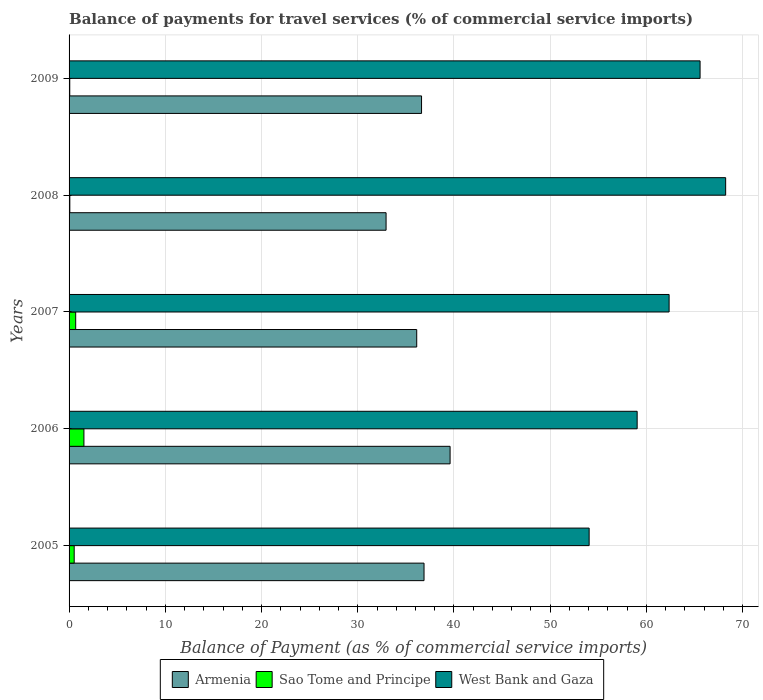How many groups of bars are there?
Ensure brevity in your answer.  5. Are the number of bars per tick equal to the number of legend labels?
Your answer should be very brief. Yes. Are the number of bars on each tick of the Y-axis equal?
Make the answer very short. Yes. What is the label of the 5th group of bars from the top?
Your answer should be compact. 2005. What is the balance of payments for travel services in Armenia in 2006?
Give a very brief answer. 39.6. Across all years, what is the maximum balance of payments for travel services in Sao Tome and Principe?
Your answer should be very brief. 1.54. Across all years, what is the minimum balance of payments for travel services in Armenia?
Offer a terse response. 32.94. What is the total balance of payments for travel services in West Bank and Gaza in the graph?
Give a very brief answer. 309.24. What is the difference between the balance of payments for travel services in Sao Tome and Principe in 2006 and that in 2007?
Your response must be concise. 0.86. What is the difference between the balance of payments for travel services in Sao Tome and Principe in 2006 and the balance of payments for travel services in West Bank and Gaza in 2005?
Your answer should be very brief. -52.5. What is the average balance of payments for travel services in West Bank and Gaza per year?
Offer a terse response. 61.85. In the year 2008, what is the difference between the balance of payments for travel services in West Bank and Gaza and balance of payments for travel services in Sao Tome and Principe?
Provide a short and direct response. 68.15. In how many years, is the balance of payments for travel services in Armenia greater than 34 %?
Your answer should be very brief. 4. What is the ratio of the balance of payments for travel services in Armenia in 2005 to that in 2007?
Offer a very short reply. 1.02. Is the balance of payments for travel services in West Bank and Gaza in 2008 less than that in 2009?
Your answer should be very brief. No. What is the difference between the highest and the second highest balance of payments for travel services in Sao Tome and Principe?
Your response must be concise. 0.86. What is the difference between the highest and the lowest balance of payments for travel services in Armenia?
Your answer should be compact. 6.65. What does the 1st bar from the top in 2009 represents?
Make the answer very short. West Bank and Gaza. What does the 2nd bar from the bottom in 2007 represents?
Ensure brevity in your answer.  Sao Tome and Principe. Is it the case that in every year, the sum of the balance of payments for travel services in Sao Tome and Principe and balance of payments for travel services in Armenia is greater than the balance of payments for travel services in West Bank and Gaza?
Make the answer very short. No. Are all the bars in the graph horizontal?
Offer a terse response. Yes. How many years are there in the graph?
Ensure brevity in your answer.  5. What is the difference between two consecutive major ticks on the X-axis?
Your answer should be compact. 10. Are the values on the major ticks of X-axis written in scientific E-notation?
Your response must be concise. No. Does the graph contain any zero values?
Give a very brief answer. No. Where does the legend appear in the graph?
Your answer should be very brief. Bottom center. How many legend labels are there?
Give a very brief answer. 3. What is the title of the graph?
Your answer should be compact. Balance of payments for travel services (% of commercial service imports). What is the label or title of the X-axis?
Your response must be concise. Balance of Payment (as % of commercial service imports). What is the Balance of Payment (as % of commercial service imports) in Armenia in 2005?
Make the answer very short. 36.89. What is the Balance of Payment (as % of commercial service imports) of Sao Tome and Principe in 2005?
Your response must be concise. 0.53. What is the Balance of Payment (as % of commercial service imports) of West Bank and Gaza in 2005?
Your response must be concise. 54.05. What is the Balance of Payment (as % of commercial service imports) in Armenia in 2006?
Offer a terse response. 39.6. What is the Balance of Payment (as % of commercial service imports) of Sao Tome and Principe in 2006?
Offer a very short reply. 1.54. What is the Balance of Payment (as % of commercial service imports) of West Bank and Gaza in 2006?
Provide a short and direct response. 59.04. What is the Balance of Payment (as % of commercial service imports) in Armenia in 2007?
Your answer should be compact. 36.13. What is the Balance of Payment (as % of commercial service imports) in Sao Tome and Principe in 2007?
Your response must be concise. 0.69. What is the Balance of Payment (as % of commercial service imports) of West Bank and Gaza in 2007?
Your answer should be compact. 62.36. What is the Balance of Payment (as % of commercial service imports) in Armenia in 2008?
Ensure brevity in your answer.  32.94. What is the Balance of Payment (as % of commercial service imports) of Sao Tome and Principe in 2008?
Provide a short and direct response. 0.08. What is the Balance of Payment (as % of commercial service imports) in West Bank and Gaza in 2008?
Your answer should be compact. 68.23. What is the Balance of Payment (as % of commercial service imports) in Armenia in 2009?
Your response must be concise. 36.63. What is the Balance of Payment (as % of commercial service imports) in Sao Tome and Principe in 2009?
Provide a short and direct response. 0.07. What is the Balance of Payment (as % of commercial service imports) in West Bank and Gaza in 2009?
Your response must be concise. 65.57. Across all years, what is the maximum Balance of Payment (as % of commercial service imports) of Armenia?
Provide a succinct answer. 39.6. Across all years, what is the maximum Balance of Payment (as % of commercial service imports) of Sao Tome and Principe?
Your response must be concise. 1.54. Across all years, what is the maximum Balance of Payment (as % of commercial service imports) of West Bank and Gaza?
Ensure brevity in your answer.  68.23. Across all years, what is the minimum Balance of Payment (as % of commercial service imports) in Armenia?
Provide a short and direct response. 32.94. Across all years, what is the minimum Balance of Payment (as % of commercial service imports) in Sao Tome and Principe?
Provide a short and direct response. 0.07. Across all years, what is the minimum Balance of Payment (as % of commercial service imports) of West Bank and Gaza?
Keep it short and to the point. 54.05. What is the total Balance of Payment (as % of commercial service imports) in Armenia in the graph?
Provide a succinct answer. 182.18. What is the total Balance of Payment (as % of commercial service imports) of Sao Tome and Principe in the graph?
Provide a succinct answer. 2.91. What is the total Balance of Payment (as % of commercial service imports) in West Bank and Gaza in the graph?
Give a very brief answer. 309.24. What is the difference between the Balance of Payment (as % of commercial service imports) of Armenia in 2005 and that in 2006?
Provide a short and direct response. -2.71. What is the difference between the Balance of Payment (as % of commercial service imports) in Sao Tome and Principe in 2005 and that in 2006?
Keep it short and to the point. -1.01. What is the difference between the Balance of Payment (as % of commercial service imports) in West Bank and Gaza in 2005 and that in 2006?
Your answer should be very brief. -4.99. What is the difference between the Balance of Payment (as % of commercial service imports) in Armenia in 2005 and that in 2007?
Provide a succinct answer. 0.76. What is the difference between the Balance of Payment (as % of commercial service imports) in Sao Tome and Principe in 2005 and that in 2007?
Your answer should be compact. -0.16. What is the difference between the Balance of Payment (as % of commercial service imports) in West Bank and Gaza in 2005 and that in 2007?
Your answer should be compact. -8.31. What is the difference between the Balance of Payment (as % of commercial service imports) in Armenia in 2005 and that in 2008?
Your answer should be very brief. 3.94. What is the difference between the Balance of Payment (as % of commercial service imports) in Sao Tome and Principe in 2005 and that in 2008?
Your response must be concise. 0.45. What is the difference between the Balance of Payment (as % of commercial service imports) in West Bank and Gaza in 2005 and that in 2008?
Keep it short and to the point. -14.19. What is the difference between the Balance of Payment (as % of commercial service imports) in Armenia in 2005 and that in 2009?
Your response must be concise. 0.26. What is the difference between the Balance of Payment (as % of commercial service imports) of Sao Tome and Principe in 2005 and that in 2009?
Offer a terse response. 0.46. What is the difference between the Balance of Payment (as % of commercial service imports) of West Bank and Gaza in 2005 and that in 2009?
Offer a very short reply. -11.53. What is the difference between the Balance of Payment (as % of commercial service imports) of Armenia in 2006 and that in 2007?
Provide a succinct answer. 3.47. What is the difference between the Balance of Payment (as % of commercial service imports) of Sao Tome and Principe in 2006 and that in 2007?
Your response must be concise. 0.86. What is the difference between the Balance of Payment (as % of commercial service imports) of West Bank and Gaza in 2006 and that in 2007?
Provide a short and direct response. -3.32. What is the difference between the Balance of Payment (as % of commercial service imports) of Armenia in 2006 and that in 2008?
Give a very brief answer. 6.65. What is the difference between the Balance of Payment (as % of commercial service imports) of Sao Tome and Principe in 2006 and that in 2008?
Offer a terse response. 1.47. What is the difference between the Balance of Payment (as % of commercial service imports) of West Bank and Gaza in 2006 and that in 2008?
Offer a terse response. -9.2. What is the difference between the Balance of Payment (as % of commercial service imports) in Armenia in 2006 and that in 2009?
Offer a terse response. 2.97. What is the difference between the Balance of Payment (as % of commercial service imports) of Sao Tome and Principe in 2006 and that in 2009?
Your response must be concise. 1.47. What is the difference between the Balance of Payment (as % of commercial service imports) in West Bank and Gaza in 2006 and that in 2009?
Offer a very short reply. -6.54. What is the difference between the Balance of Payment (as % of commercial service imports) of Armenia in 2007 and that in 2008?
Keep it short and to the point. 3.18. What is the difference between the Balance of Payment (as % of commercial service imports) in Sao Tome and Principe in 2007 and that in 2008?
Provide a short and direct response. 0.61. What is the difference between the Balance of Payment (as % of commercial service imports) of West Bank and Gaza in 2007 and that in 2008?
Ensure brevity in your answer.  -5.88. What is the difference between the Balance of Payment (as % of commercial service imports) of Armenia in 2007 and that in 2009?
Your answer should be compact. -0.5. What is the difference between the Balance of Payment (as % of commercial service imports) in Sao Tome and Principe in 2007 and that in 2009?
Keep it short and to the point. 0.62. What is the difference between the Balance of Payment (as % of commercial service imports) of West Bank and Gaza in 2007 and that in 2009?
Ensure brevity in your answer.  -3.22. What is the difference between the Balance of Payment (as % of commercial service imports) in Armenia in 2008 and that in 2009?
Make the answer very short. -3.69. What is the difference between the Balance of Payment (as % of commercial service imports) of Sao Tome and Principe in 2008 and that in 2009?
Offer a very short reply. 0.01. What is the difference between the Balance of Payment (as % of commercial service imports) in West Bank and Gaza in 2008 and that in 2009?
Offer a very short reply. 2.66. What is the difference between the Balance of Payment (as % of commercial service imports) of Armenia in 2005 and the Balance of Payment (as % of commercial service imports) of Sao Tome and Principe in 2006?
Ensure brevity in your answer.  35.34. What is the difference between the Balance of Payment (as % of commercial service imports) in Armenia in 2005 and the Balance of Payment (as % of commercial service imports) in West Bank and Gaza in 2006?
Your response must be concise. -22.15. What is the difference between the Balance of Payment (as % of commercial service imports) in Sao Tome and Principe in 2005 and the Balance of Payment (as % of commercial service imports) in West Bank and Gaza in 2006?
Provide a succinct answer. -58.5. What is the difference between the Balance of Payment (as % of commercial service imports) in Armenia in 2005 and the Balance of Payment (as % of commercial service imports) in Sao Tome and Principe in 2007?
Make the answer very short. 36.2. What is the difference between the Balance of Payment (as % of commercial service imports) in Armenia in 2005 and the Balance of Payment (as % of commercial service imports) in West Bank and Gaza in 2007?
Your answer should be compact. -25.47. What is the difference between the Balance of Payment (as % of commercial service imports) in Sao Tome and Principe in 2005 and the Balance of Payment (as % of commercial service imports) in West Bank and Gaza in 2007?
Your response must be concise. -61.82. What is the difference between the Balance of Payment (as % of commercial service imports) in Armenia in 2005 and the Balance of Payment (as % of commercial service imports) in Sao Tome and Principe in 2008?
Keep it short and to the point. 36.81. What is the difference between the Balance of Payment (as % of commercial service imports) of Armenia in 2005 and the Balance of Payment (as % of commercial service imports) of West Bank and Gaza in 2008?
Offer a very short reply. -31.35. What is the difference between the Balance of Payment (as % of commercial service imports) of Sao Tome and Principe in 2005 and the Balance of Payment (as % of commercial service imports) of West Bank and Gaza in 2008?
Keep it short and to the point. -67.7. What is the difference between the Balance of Payment (as % of commercial service imports) in Armenia in 2005 and the Balance of Payment (as % of commercial service imports) in Sao Tome and Principe in 2009?
Keep it short and to the point. 36.82. What is the difference between the Balance of Payment (as % of commercial service imports) of Armenia in 2005 and the Balance of Payment (as % of commercial service imports) of West Bank and Gaza in 2009?
Provide a succinct answer. -28.69. What is the difference between the Balance of Payment (as % of commercial service imports) of Sao Tome and Principe in 2005 and the Balance of Payment (as % of commercial service imports) of West Bank and Gaza in 2009?
Offer a very short reply. -65.04. What is the difference between the Balance of Payment (as % of commercial service imports) of Armenia in 2006 and the Balance of Payment (as % of commercial service imports) of Sao Tome and Principe in 2007?
Ensure brevity in your answer.  38.91. What is the difference between the Balance of Payment (as % of commercial service imports) of Armenia in 2006 and the Balance of Payment (as % of commercial service imports) of West Bank and Gaza in 2007?
Offer a terse response. -22.76. What is the difference between the Balance of Payment (as % of commercial service imports) of Sao Tome and Principe in 2006 and the Balance of Payment (as % of commercial service imports) of West Bank and Gaza in 2007?
Your answer should be very brief. -60.81. What is the difference between the Balance of Payment (as % of commercial service imports) in Armenia in 2006 and the Balance of Payment (as % of commercial service imports) in Sao Tome and Principe in 2008?
Give a very brief answer. 39.52. What is the difference between the Balance of Payment (as % of commercial service imports) in Armenia in 2006 and the Balance of Payment (as % of commercial service imports) in West Bank and Gaza in 2008?
Keep it short and to the point. -28.64. What is the difference between the Balance of Payment (as % of commercial service imports) of Sao Tome and Principe in 2006 and the Balance of Payment (as % of commercial service imports) of West Bank and Gaza in 2008?
Your answer should be very brief. -66.69. What is the difference between the Balance of Payment (as % of commercial service imports) of Armenia in 2006 and the Balance of Payment (as % of commercial service imports) of Sao Tome and Principe in 2009?
Keep it short and to the point. 39.52. What is the difference between the Balance of Payment (as % of commercial service imports) of Armenia in 2006 and the Balance of Payment (as % of commercial service imports) of West Bank and Gaza in 2009?
Make the answer very short. -25.98. What is the difference between the Balance of Payment (as % of commercial service imports) in Sao Tome and Principe in 2006 and the Balance of Payment (as % of commercial service imports) in West Bank and Gaza in 2009?
Your response must be concise. -64.03. What is the difference between the Balance of Payment (as % of commercial service imports) of Armenia in 2007 and the Balance of Payment (as % of commercial service imports) of Sao Tome and Principe in 2008?
Your answer should be very brief. 36.05. What is the difference between the Balance of Payment (as % of commercial service imports) of Armenia in 2007 and the Balance of Payment (as % of commercial service imports) of West Bank and Gaza in 2008?
Give a very brief answer. -32.1. What is the difference between the Balance of Payment (as % of commercial service imports) of Sao Tome and Principe in 2007 and the Balance of Payment (as % of commercial service imports) of West Bank and Gaza in 2008?
Ensure brevity in your answer.  -67.54. What is the difference between the Balance of Payment (as % of commercial service imports) in Armenia in 2007 and the Balance of Payment (as % of commercial service imports) in Sao Tome and Principe in 2009?
Offer a very short reply. 36.06. What is the difference between the Balance of Payment (as % of commercial service imports) in Armenia in 2007 and the Balance of Payment (as % of commercial service imports) in West Bank and Gaza in 2009?
Provide a short and direct response. -29.45. What is the difference between the Balance of Payment (as % of commercial service imports) in Sao Tome and Principe in 2007 and the Balance of Payment (as % of commercial service imports) in West Bank and Gaza in 2009?
Keep it short and to the point. -64.89. What is the difference between the Balance of Payment (as % of commercial service imports) in Armenia in 2008 and the Balance of Payment (as % of commercial service imports) in Sao Tome and Principe in 2009?
Make the answer very short. 32.87. What is the difference between the Balance of Payment (as % of commercial service imports) of Armenia in 2008 and the Balance of Payment (as % of commercial service imports) of West Bank and Gaza in 2009?
Provide a short and direct response. -32.63. What is the difference between the Balance of Payment (as % of commercial service imports) of Sao Tome and Principe in 2008 and the Balance of Payment (as % of commercial service imports) of West Bank and Gaza in 2009?
Offer a very short reply. -65.5. What is the average Balance of Payment (as % of commercial service imports) in Armenia per year?
Offer a terse response. 36.44. What is the average Balance of Payment (as % of commercial service imports) of Sao Tome and Principe per year?
Offer a terse response. 0.58. What is the average Balance of Payment (as % of commercial service imports) in West Bank and Gaza per year?
Ensure brevity in your answer.  61.85. In the year 2005, what is the difference between the Balance of Payment (as % of commercial service imports) in Armenia and Balance of Payment (as % of commercial service imports) in Sao Tome and Principe?
Offer a terse response. 36.36. In the year 2005, what is the difference between the Balance of Payment (as % of commercial service imports) in Armenia and Balance of Payment (as % of commercial service imports) in West Bank and Gaza?
Offer a very short reply. -17.16. In the year 2005, what is the difference between the Balance of Payment (as % of commercial service imports) in Sao Tome and Principe and Balance of Payment (as % of commercial service imports) in West Bank and Gaza?
Ensure brevity in your answer.  -53.51. In the year 2006, what is the difference between the Balance of Payment (as % of commercial service imports) in Armenia and Balance of Payment (as % of commercial service imports) in Sao Tome and Principe?
Your answer should be compact. 38.05. In the year 2006, what is the difference between the Balance of Payment (as % of commercial service imports) of Armenia and Balance of Payment (as % of commercial service imports) of West Bank and Gaza?
Your answer should be compact. -19.44. In the year 2006, what is the difference between the Balance of Payment (as % of commercial service imports) in Sao Tome and Principe and Balance of Payment (as % of commercial service imports) in West Bank and Gaza?
Provide a succinct answer. -57.49. In the year 2007, what is the difference between the Balance of Payment (as % of commercial service imports) of Armenia and Balance of Payment (as % of commercial service imports) of Sao Tome and Principe?
Your answer should be very brief. 35.44. In the year 2007, what is the difference between the Balance of Payment (as % of commercial service imports) of Armenia and Balance of Payment (as % of commercial service imports) of West Bank and Gaza?
Provide a succinct answer. -26.23. In the year 2007, what is the difference between the Balance of Payment (as % of commercial service imports) of Sao Tome and Principe and Balance of Payment (as % of commercial service imports) of West Bank and Gaza?
Your answer should be very brief. -61.67. In the year 2008, what is the difference between the Balance of Payment (as % of commercial service imports) of Armenia and Balance of Payment (as % of commercial service imports) of Sao Tome and Principe?
Offer a very short reply. 32.86. In the year 2008, what is the difference between the Balance of Payment (as % of commercial service imports) in Armenia and Balance of Payment (as % of commercial service imports) in West Bank and Gaza?
Ensure brevity in your answer.  -35.29. In the year 2008, what is the difference between the Balance of Payment (as % of commercial service imports) of Sao Tome and Principe and Balance of Payment (as % of commercial service imports) of West Bank and Gaza?
Your answer should be very brief. -68.15. In the year 2009, what is the difference between the Balance of Payment (as % of commercial service imports) in Armenia and Balance of Payment (as % of commercial service imports) in Sao Tome and Principe?
Your answer should be compact. 36.56. In the year 2009, what is the difference between the Balance of Payment (as % of commercial service imports) of Armenia and Balance of Payment (as % of commercial service imports) of West Bank and Gaza?
Ensure brevity in your answer.  -28.94. In the year 2009, what is the difference between the Balance of Payment (as % of commercial service imports) in Sao Tome and Principe and Balance of Payment (as % of commercial service imports) in West Bank and Gaza?
Your answer should be compact. -65.5. What is the ratio of the Balance of Payment (as % of commercial service imports) in Armenia in 2005 to that in 2006?
Provide a short and direct response. 0.93. What is the ratio of the Balance of Payment (as % of commercial service imports) in Sao Tome and Principe in 2005 to that in 2006?
Offer a very short reply. 0.34. What is the ratio of the Balance of Payment (as % of commercial service imports) of West Bank and Gaza in 2005 to that in 2006?
Your answer should be very brief. 0.92. What is the ratio of the Balance of Payment (as % of commercial service imports) in Armenia in 2005 to that in 2007?
Make the answer very short. 1.02. What is the ratio of the Balance of Payment (as % of commercial service imports) in Sao Tome and Principe in 2005 to that in 2007?
Your response must be concise. 0.77. What is the ratio of the Balance of Payment (as % of commercial service imports) of West Bank and Gaza in 2005 to that in 2007?
Offer a very short reply. 0.87. What is the ratio of the Balance of Payment (as % of commercial service imports) of Armenia in 2005 to that in 2008?
Keep it short and to the point. 1.12. What is the ratio of the Balance of Payment (as % of commercial service imports) in Sao Tome and Principe in 2005 to that in 2008?
Your answer should be compact. 6.76. What is the ratio of the Balance of Payment (as % of commercial service imports) of West Bank and Gaza in 2005 to that in 2008?
Make the answer very short. 0.79. What is the ratio of the Balance of Payment (as % of commercial service imports) of Sao Tome and Principe in 2005 to that in 2009?
Keep it short and to the point. 7.49. What is the ratio of the Balance of Payment (as % of commercial service imports) of West Bank and Gaza in 2005 to that in 2009?
Provide a short and direct response. 0.82. What is the ratio of the Balance of Payment (as % of commercial service imports) in Armenia in 2006 to that in 2007?
Your answer should be compact. 1.1. What is the ratio of the Balance of Payment (as % of commercial service imports) in Sao Tome and Principe in 2006 to that in 2007?
Your response must be concise. 2.24. What is the ratio of the Balance of Payment (as % of commercial service imports) of West Bank and Gaza in 2006 to that in 2007?
Provide a short and direct response. 0.95. What is the ratio of the Balance of Payment (as % of commercial service imports) in Armenia in 2006 to that in 2008?
Keep it short and to the point. 1.2. What is the ratio of the Balance of Payment (as % of commercial service imports) in Sao Tome and Principe in 2006 to that in 2008?
Your response must be concise. 19.63. What is the ratio of the Balance of Payment (as % of commercial service imports) of West Bank and Gaza in 2006 to that in 2008?
Provide a short and direct response. 0.87. What is the ratio of the Balance of Payment (as % of commercial service imports) of Armenia in 2006 to that in 2009?
Offer a terse response. 1.08. What is the ratio of the Balance of Payment (as % of commercial service imports) in Sao Tome and Principe in 2006 to that in 2009?
Provide a succinct answer. 21.73. What is the ratio of the Balance of Payment (as % of commercial service imports) of West Bank and Gaza in 2006 to that in 2009?
Offer a terse response. 0.9. What is the ratio of the Balance of Payment (as % of commercial service imports) in Armenia in 2007 to that in 2008?
Provide a succinct answer. 1.1. What is the ratio of the Balance of Payment (as % of commercial service imports) of Sao Tome and Principe in 2007 to that in 2008?
Offer a very short reply. 8.75. What is the ratio of the Balance of Payment (as % of commercial service imports) in West Bank and Gaza in 2007 to that in 2008?
Your response must be concise. 0.91. What is the ratio of the Balance of Payment (as % of commercial service imports) in Armenia in 2007 to that in 2009?
Your response must be concise. 0.99. What is the ratio of the Balance of Payment (as % of commercial service imports) of Sao Tome and Principe in 2007 to that in 2009?
Your answer should be compact. 9.69. What is the ratio of the Balance of Payment (as % of commercial service imports) in West Bank and Gaza in 2007 to that in 2009?
Your response must be concise. 0.95. What is the ratio of the Balance of Payment (as % of commercial service imports) of Armenia in 2008 to that in 2009?
Keep it short and to the point. 0.9. What is the ratio of the Balance of Payment (as % of commercial service imports) of Sao Tome and Principe in 2008 to that in 2009?
Your response must be concise. 1.11. What is the ratio of the Balance of Payment (as % of commercial service imports) in West Bank and Gaza in 2008 to that in 2009?
Provide a short and direct response. 1.04. What is the difference between the highest and the second highest Balance of Payment (as % of commercial service imports) of Armenia?
Give a very brief answer. 2.71. What is the difference between the highest and the second highest Balance of Payment (as % of commercial service imports) in Sao Tome and Principe?
Make the answer very short. 0.86. What is the difference between the highest and the second highest Balance of Payment (as % of commercial service imports) of West Bank and Gaza?
Provide a short and direct response. 2.66. What is the difference between the highest and the lowest Balance of Payment (as % of commercial service imports) in Armenia?
Ensure brevity in your answer.  6.65. What is the difference between the highest and the lowest Balance of Payment (as % of commercial service imports) of Sao Tome and Principe?
Provide a short and direct response. 1.47. What is the difference between the highest and the lowest Balance of Payment (as % of commercial service imports) in West Bank and Gaza?
Provide a short and direct response. 14.19. 